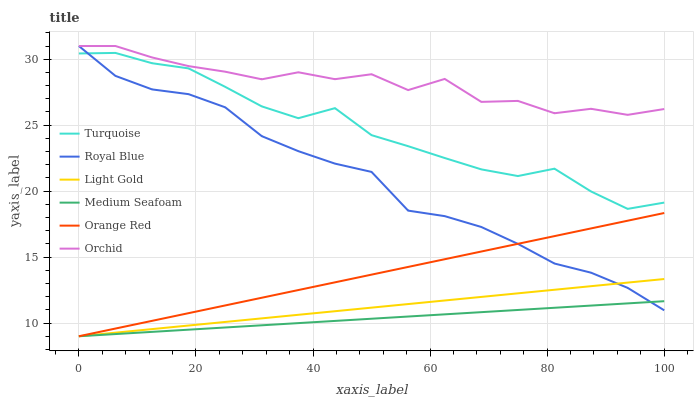Does Medium Seafoam have the minimum area under the curve?
Answer yes or no. Yes. Does Orchid have the maximum area under the curve?
Answer yes or no. Yes. Does Orange Red have the minimum area under the curve?
Answer yes or no. No. Does Orange Red have the maximum area under the curve?
Answer yes or no. No. Is Light Gold the smoothest?
Answer yes or no. Yes. Is Orchid the roughest?
Answer yes or no. Yes. Is Orange Red the smoothest?
Answer yes or no. No. Is Orange Red the roughest?
Answer yes or no. No. Does Royal Blue have the lowest value?
Answer yes or no. No. Does Orchid have the highest value?
Answer yes or no. Yes. Does Orange Red have the highest value?
Answer yes or no. No. Is Medium Seafoam less than Orchid?
Answer yes or no. Yes. Is Turquoise greater than Light Gold?
Answer yes or no. Yes. Does Royal Blue intersect Orchid?
Answer yes or no. Yes. Is Royal Blue less than Orchid?
Answer yes or no. No. Is Royal Blue greater than Orchid?
Answer yes or no. No. Does Medium Seafoam intersect Orchid?
Answer yes or no. No. 